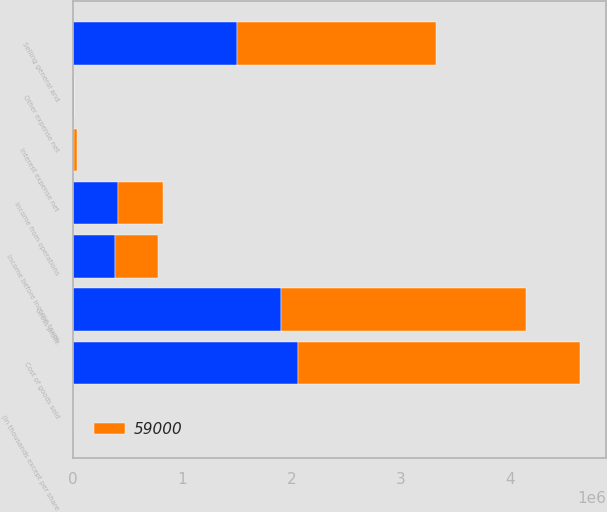Convert chart to OTSL. <chart><loc_0><loc_0><loc_500><loc_500><stacked_bar_chart><ecel><fcel>(In thousands except per share<fcel>Cost of goods sold<fcel>Gross profit<fcel>Selling general and<fcel>Income from operations<fcel>Interest expense net<fcel>Other expense net<fcel>Income before income taxes<nl><fcel>59000<fcel>2016<fcel>2.58472e+06<fcel>2.24061e+06<fcel>1.82314e+06<fcel>417471<fcel>26434<fcel>2755<fcel>388282<nl><fcel>nan<fcel>2015<fcel>2.05777e+06<fcel>1.90555e+06<fcel>1.497e+06<fcel>408547<fcel>14628<fcel>7234<fcel>386685<nl></chart> 